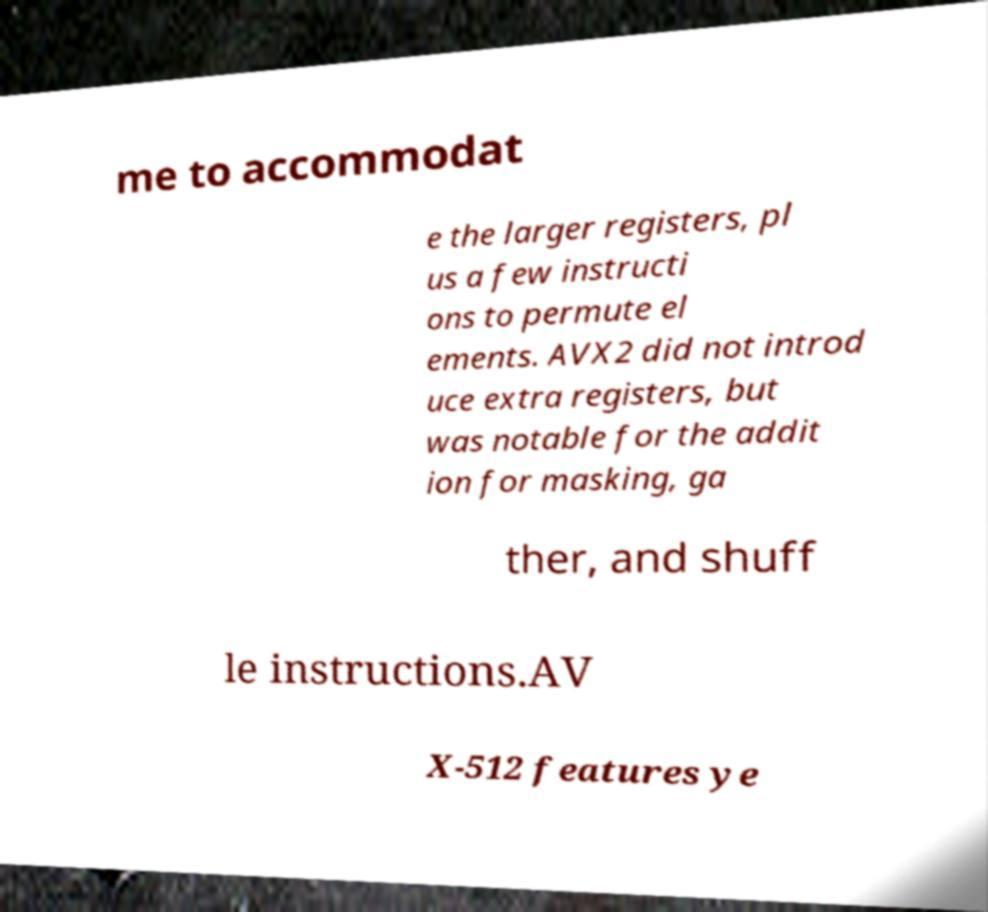Can you accurately transcribe the text from the provided image for me? me to accommodat e the larger registers, pl us a few instructi ons to permute el ements. AVX2 did not introd uce extra registers, but was notable for the addit ion for masking, ga ther, and shuff le instructions.AV X-512 features ye 